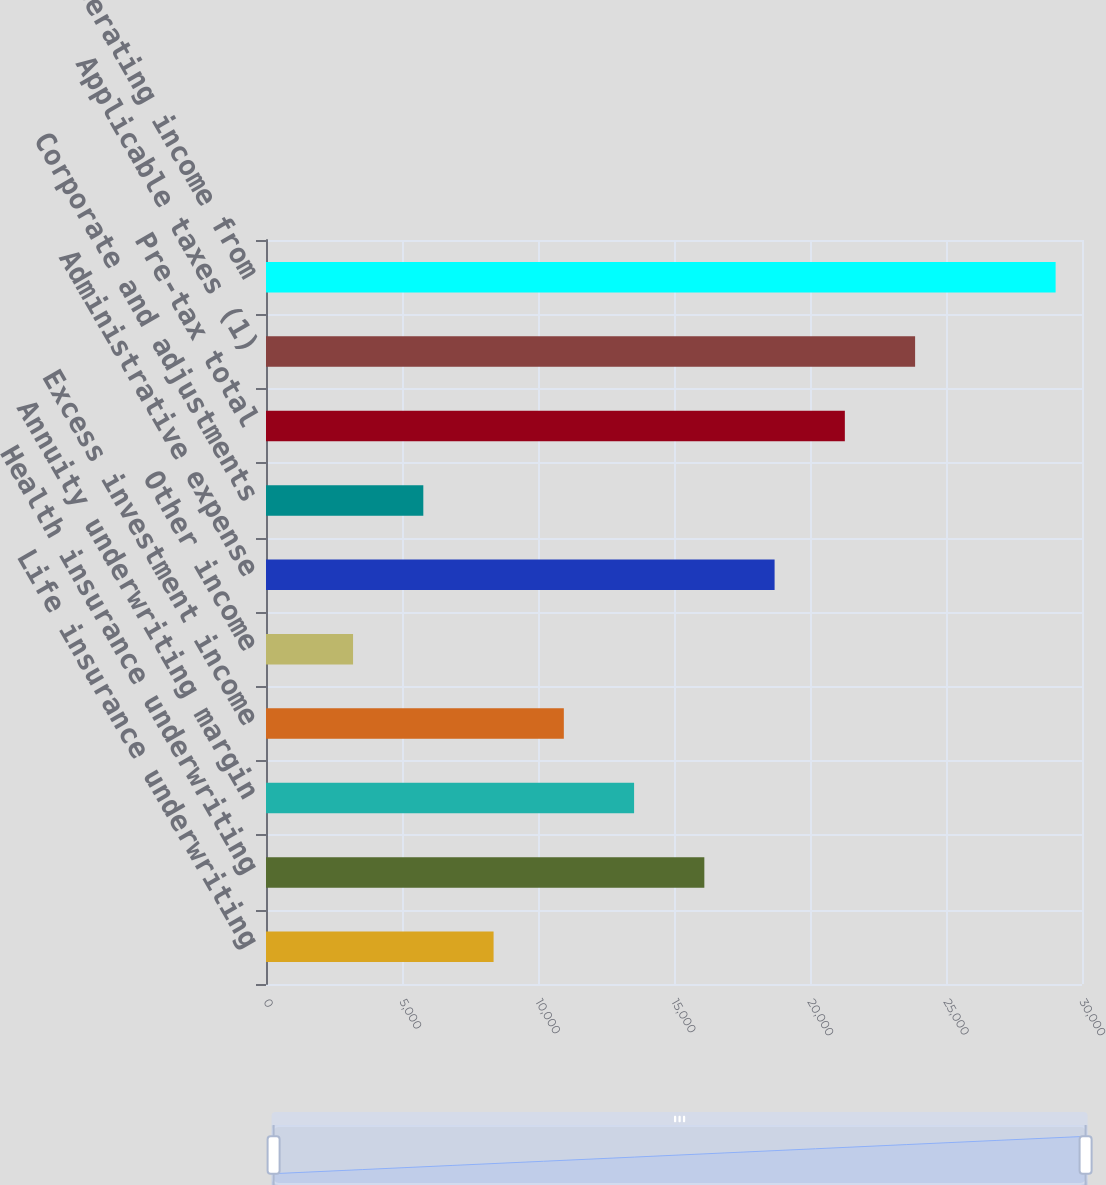Convert chart. <chart><loc_0><loc_0><loc_500><loc_500><bar_chart><fcel>Life insurance underwriting<fcel>Health insurance underwriting<fcel>Annuity underwriting margin<fcel>Excess investment income<fcel>Other income<fcel>Administrative expense<fcel>Corporate and adjustments<fcel>Pre-tax total<fcel>Applicable taxes (1)<fcel>Net operating income from<nl><fcel>8366.7<fcel>16115.4<fcel>13532.5<fcel>10949.6<fcel>3200.9<fcel>18698.3<fcel>5783.8<fcel>21281.2<fcel>23864.1<fcel>29029.9<nl></chart> 